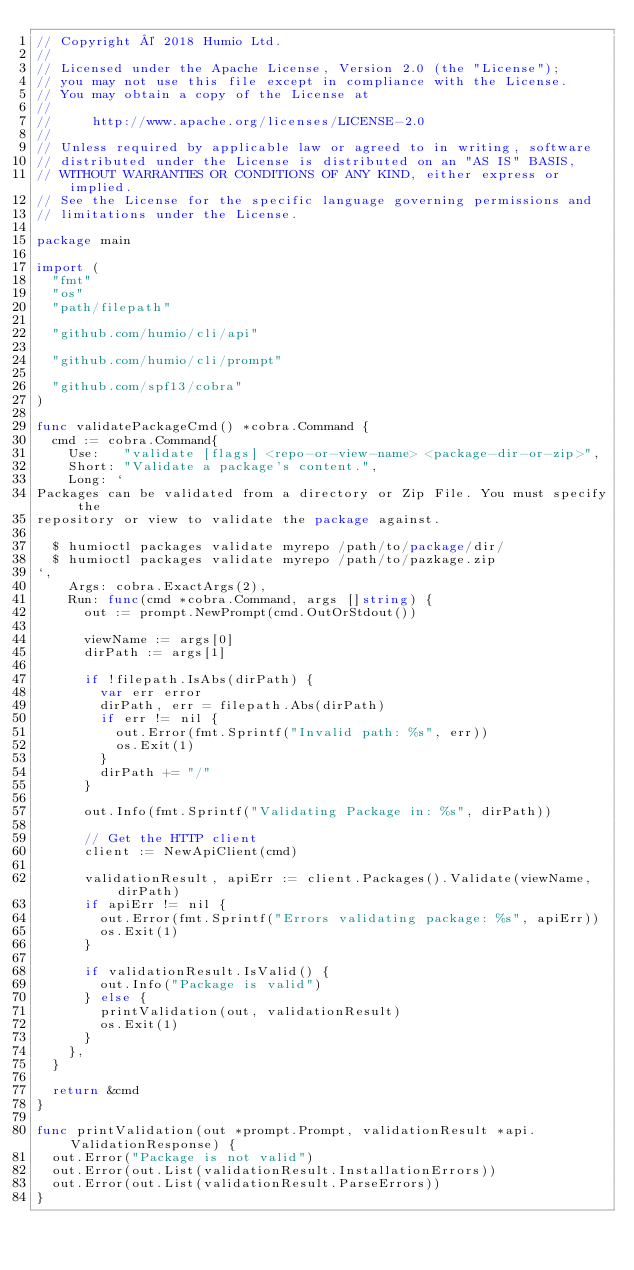Convert code to text. <code><loc_0><loc_0><loc_500><loc_500><_Go_>// Copyright © 2018 Humio Ltd.
//
// Licensed under the Apache License, Version 2.0 (the "License");
// you may not use this file except in compliance with the License.
// You may obtain a copy of the License at
//
//     http://www.apache.org/licenses/LICENSE-2.0
//
// Unless required by applicable law or agreed to in writing, software
// distributed under the License is distributed on an "AS IS" BASIS,
// WITHOUT WARRANTIES OR CONDITIONS OF ANY KIND, either express or implied.
// See the License for the specific language governing permissions and
// limitations under the License.

package main

import (
	"fmt"
	"os"
	"path/filepath"

	"github.com/humio/cli/api"

	"github.com/humio/cli/prompt"

	"github.com/spf13/cobra"
)

func validatePackageCmd() *cobra.Command {
	cmd := cobra.Command{
		Use:   "validate [flags] <repo-or-view-name> <package-dir-or-zip>",
		Short: "Validate a package's content.",
		Long: `
Packages can be validated from a directory or Zip File. You must specify the
repository or view to validate the package against.

  $ humioctl packages validate myrepo /path/to/package/dir/
  $ humioctl packages validate myrepo /path/to/pazkage.zip
`,
		Args: cobra.ExactArgs(2),
		Run: func(cmd *cobra.Command, args []string) {
			out := prompt.NewPrompt(cmd.OutOrStdout())

			viewName := args[0]
			dirPath := args[1]

			if !filepath.IsAbs(dirPath) {
				var err error
				dirPath, err = filepath.Abs(dirPath)
				if err != nil {
					out.Error(fmt.Sprintf("Invalid path: %s", err))
					os.Exit(1)
				}
				dirPath += "/"
			}

			out.Info(fmt.Sprintf("Validating Package in: %s", dirPath))

			// Get the HTTP client
			client := NewApiClient(cmd)

			validationResult, apiErr := client.Packages().Validate(viewName, dirPath)
			if apiErr != nil {
				out.Error(fmt.Sprintf("Errors validating package: %s", apiErr))
				os.Exit(1)
			}

			if validationResult.IsValid() {
				out.Info("Package is valid")
			} else {
				printValidation(out, validationResult)
				os.Exit(1)
			}
		},
	}

	return &cmd
}

func printValidation(out *prompt.Prompt, validationResult *api.ValidationResponse) {
	out.Error("Package is not valid")
	out.Error(out.List(validationResult.InstallationErrors))
	out.Error(out.List(validationResult.ParseErrors))
}
</code> 